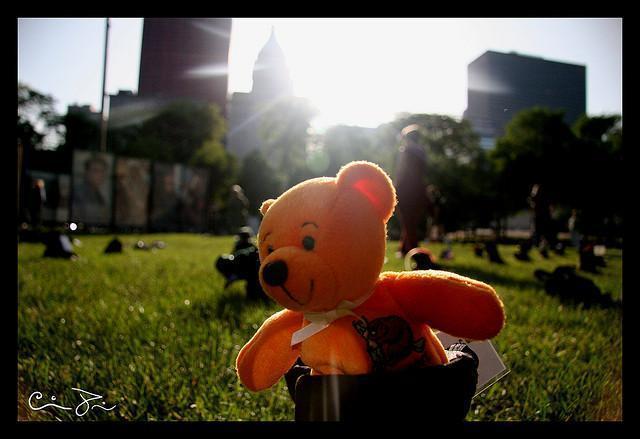How many people are in the picture?
Give a very brief answer. 2. 